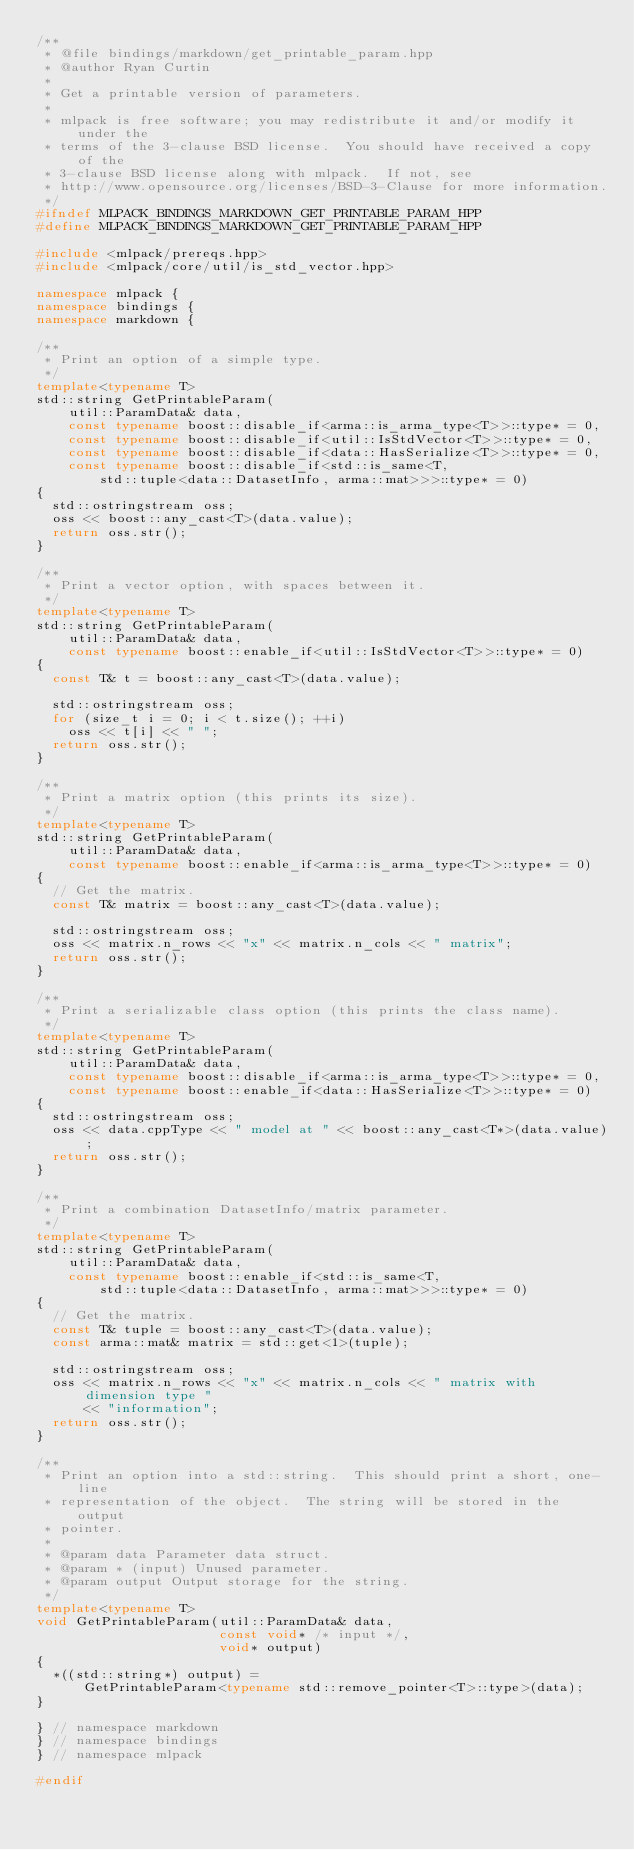Convert code to text. <code><loc_0><loc_0><loc_500><loc_500><_C++_>/**
 * @file bindings/markdown/get_printable_param.hpp
 * @author Ryan Curtin
 *
 * Get a printable version of parameters.
 *
 * mlpack is free software; you may redistribute it and/or modify it under the
 * terms of the 3-clause BSD license.  You should have received a copy of the
 * 3-clause BSD license along with mlpack.  If not, see
 * http://www.opensource.org/licenses/BSD-3-Clause for more information.
 */
#ifndef MLPACK_BINDINGS_MARKDOWN_GET_PRINTABLE_PARAM_HPP
#define MLPACK_BINDINGS_MARKDOWN_GET_PRINTABLE_PARAM_HPP

#include <mlpack/prereqs.hpp>
#include <mlpack/core/util/is_std_vector.hpp>

namespace mlpack {
namespace bindings {
namespace markdown {

/**
 * Print an option of a simple type.
 */
template<typename T>
std::string GetPrintableParam(
    util::ParamData& data,
    const typename boost::disable_if<arma::is_arma_type<T>>::type* = 0,
    const typename boost::disable_if<util::IsStdVector<T>>::type* = 0,
    const typename boost::disable_if<data::HasSerialize<T>>::type* = 0,
    const typename boost::disable_if<std::is_same<T,
        std::tuple<data::DatasetInfo, arma::mat>>>::type* = 0)
{
  std::ostringstream oss;
  oss << boost::any_cast<T>(data.value);
  return oss.str();
}

/**
 * Print a vector option, with spaces between it.
 */
template<typename T>
std::string GetPrintableParam(
    util::ParamData& data,
    const typename boost::enable_if<util::IsStdVector<T>>::type* = 0)
{
  const T& t = boost::any_cast<T>(data.value);

  std::ostringstream oss;
  for (size_t i = 0; i < t.size(); ++i)
    oss << t[i] << " ";
  return oss.str();
}

/**
 * Print a matrix option (this prints its size).
 */
template<typename T>
std::string GetPrintableParam(
    util::ParamData& data,
    const typename boost::enable_if<arma::is_arma_type<T>>::type* = 0)
{
  // Get the matrix.
  const T& matrix = boost::any_cast<T>(data.value);

  std::ostringstream oss;
  oss << matrix.n_rows << "x" << matrix.n_cols << " matrix";
  return oss.str();
}

/**
 * Print a serializable class option (this prints the class name).
 */
template<typename T>
std::string GetPrintableParam(
    util::ParamData& data,
    const typename boost::disable_if<arma::is_arma_type<T>>::type* = 0,
    const typename boost::enable_if<data::HasSerialize<T>>::type* = 0)
{
  std::ostringstream oss;
  oss << data.cppType << " model at " << boost::any_cast<T*>(data.value);
  return oss.str();
}

/**
 * Print a combination DatasetInfo/matrix parameter.
 */
template<typename T>
std::string GetPrintableParam(
    util::ParamData& data,
    const typename boost::enable_if<std::is_same<T,
        std::tuple<data::DatasetInfo, arma::mat>>>::type* = 0)
{
  // Get the matrix.
  const T& tuple = boost::any_cast<T>(data.value);
  const arma::mat& matrix = std::get<1>(tuple);

  std::ostringstream oss;
  oss << matrix.n_rows << "x" << matrix.n_cols << " matrix with dimension type "
      << "information";
  return oss.str();
}

/**
 * Print an option into a std::string.  This should print a short, one-line
 * representation of the object.  The string will be stored in the output
 * pointer.
 *
 * @param data Parameter data struct.
 * @param * (input) Unused parameter.
 * @param output Output storage for the string.
 */
template<typename T>
void GetPrintableParam(util::ParamData& data,
                       const void* /* input */,
                       void* output)
{
  *((std::string*) output) =
      GetPrintableParam<typename std::remove_pointer<T>::type>(data);
}

} // namespace markdown
} // namespace bindings
} // namespace mlpack

#endif
</code> 